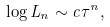<formula> <loc_0><loc_0><loc_500><loc_500>\log L _ { n } \sim c \tau ^ { n } ,</formula> 